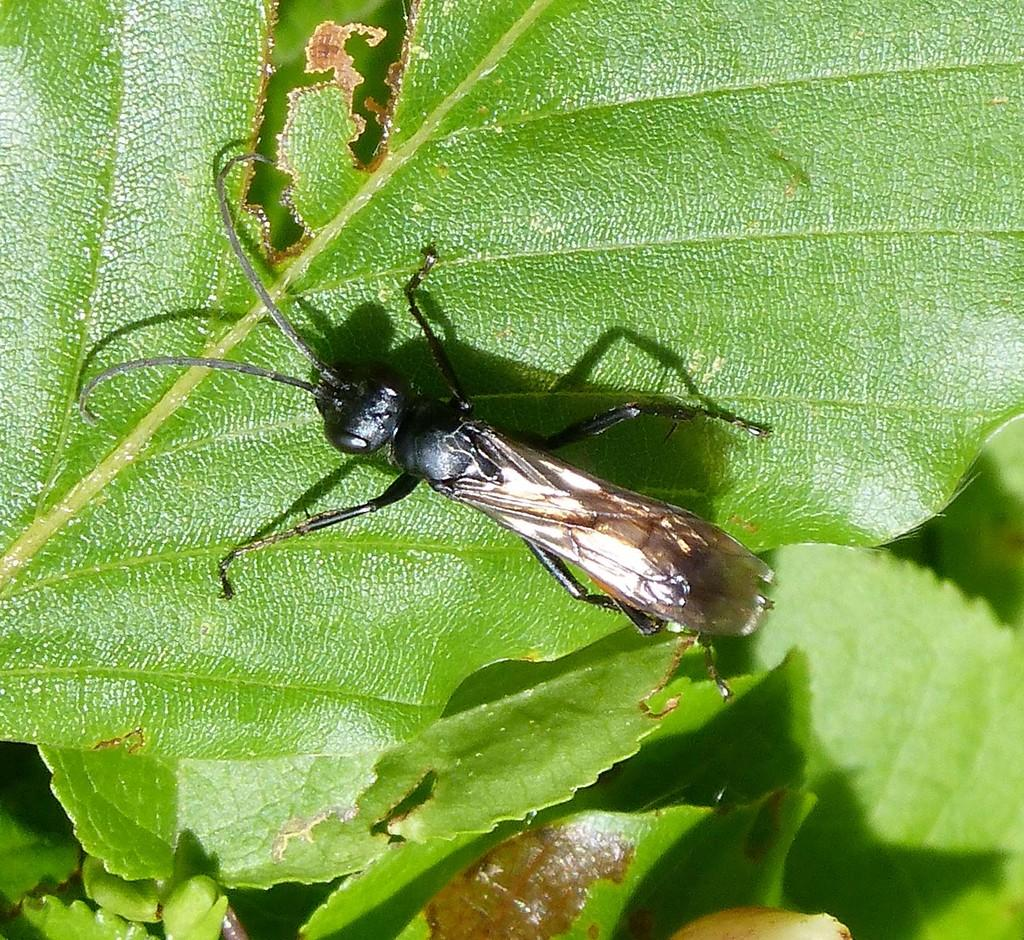What is present on the leaf in the image? There is an insect on a leaf in the image. What can be seen at the bottom of the image? There is a plant at the bottom of the image. How many rings are visible on the insect's lip in the image? There are no rings or lips present on the insect in the image. 